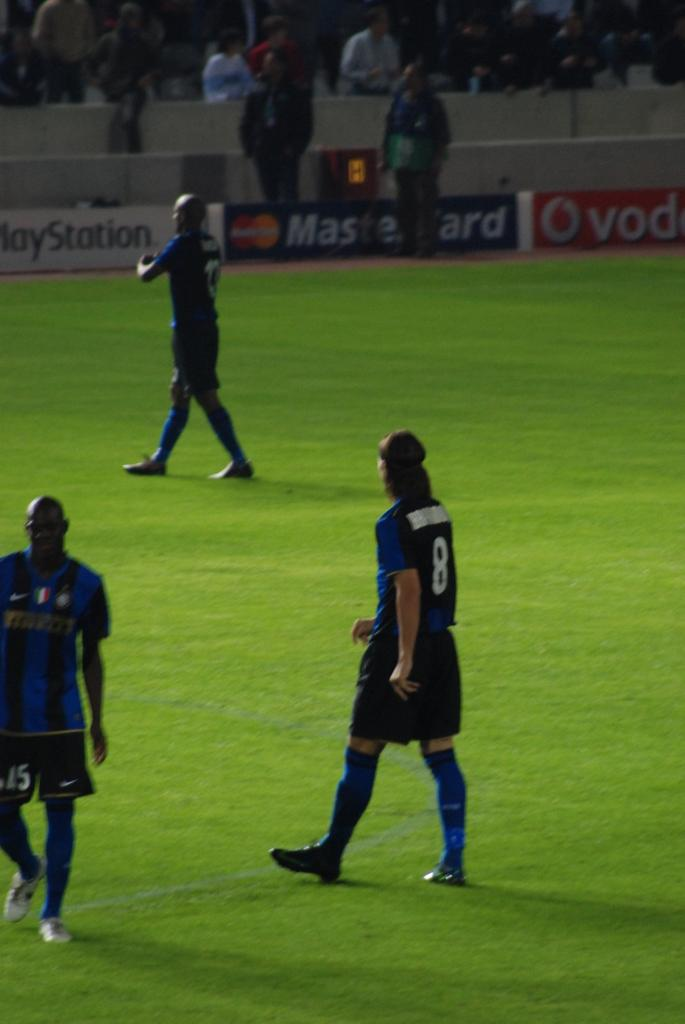Provide a one-sentence caption for the provided image. Three soccer players from the same team are on the field in those included are players 8 and 15. 